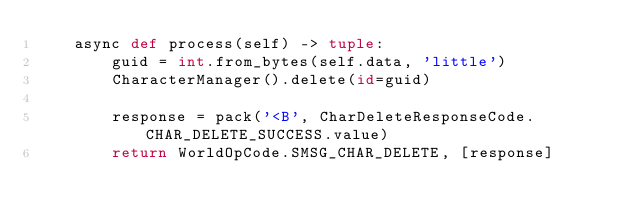<code> <loc_0><loc_0><loc_500><loc_500><_Python_>    async def process(self) -> tuple:
        guid = int.from_bytes(self.data, 'little')
        CharacterManager().delete(id=guid)

        response = pack('<B', CharDeleteResponseCode.CHAR_DELETE_SUCCESS.value)
        return WorldOpCode.SMSG_CHAR_DELETE, [response]
</code> 